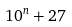<formula> <loc_0><loc_0><loc_500><loc_500>1 0 ^ { n } + 2 7</formula> 